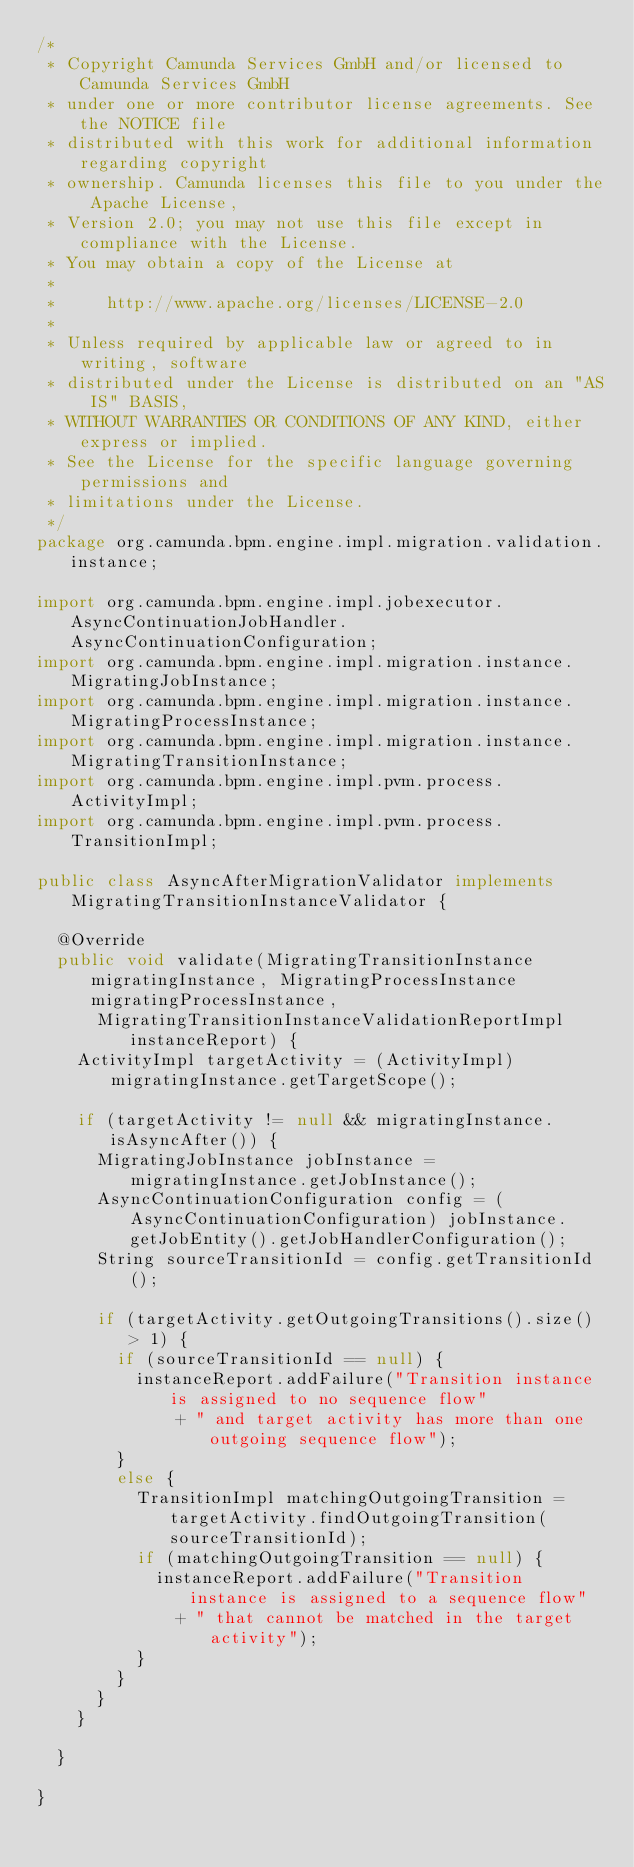Convert code to text. <code><loc_0><loc_0><loc_500><loc_500><_Java_>/*
 * Copyright Camunda Services GmbH and/or licensed to Camunda Services GmbH
 * under one or more contributor license agreements. See the NOTICE file
 * distributed with this work for additional information regarding copyright
 * ownership. Camunda licenses this file to you under the Apache License,
 * Version 2.0; you may not use this file except in compliance with the License.
 * You may obtain a copy of the License at
 *
 *     http://www.apache.org/licenses/LICENSE-2.0
 *
 * Unless required by applicable law or agreed to in writing, software
 * distributed under the License is distributed on an "AS IS" BASIS,
 * WITHOUT WARRANTIES OR CONDITIONS OF ANY KIND, either express or implied.
 * See the License for the specific language governing permissions and
 * limitations under the License.
 */
package org.camunda.bpm.engine.impl.migration.validation.instance;

import org.camunda.bpm.engine.impl.jobexecutor.AsyncContinuationJobHandler.AsyncContinuationConfiguration;
import org.camunda.bpm.engine.impl.migration.instance.MigratingJobInstance;
import org.camunda.bpm.engine.impl.migration.instance.MigratingProcessInstance;
import org.camunda.bpm.engine.impl.migration.instance.MigratingTransitionInstance;
import org.camunda.bpm.engine.impl.pvm.process.ActivityImpl;
import org.camunda.bpm.engine.impl.pvm.process.TransitionImpl;

public class AsyncAfterMigrationValidator implements MigratingTransitionInstanceValidator {

  @Override
  public void validate(MigratingTransitionInstance migratingInstance, MigratingProcessInstance migratingProcessInstance,
      MigratingTransitionInstanceValidationReportImpl instanceReport) {
    ActivityImpl targetActivity = (ActivityImpl) migratingInstance.getTargetScope();

    if (targetActivity != null && migratingInstance.isAsyncAfter()) {
      MigratingJobInstance jobInstance = migratingInstance.getJobInstance();
      AsyncContinuationConfiguration config = (AsyncContinuationConfiguration) jobInstance.getJobEntity().getJobHandlerConfiguration();
      String sourceTransitionId = config.getTransitionId();

      if (targetActivity.getOutgoingTransitions().size() > 1) {
        if (sourceTransitionId == null) {
          instanceReport.addFailure("Transition instance is assigned to no sequence flow"
              + " and target activity has more than one outgoing sequence flow");
        }
        else {
          TransitionImpl matchingOutgoingTransition = targetActivity.findOutgoingTransition(sourceTransitionId);
          if (matchingOutgoingTransition == null) {
            instanceReport.addFailure("Transition instance is assigned to a sequence flow"
              + " that cannot be matched in the target activity");
          }
        }
      }
    }

  }

}
</code> 